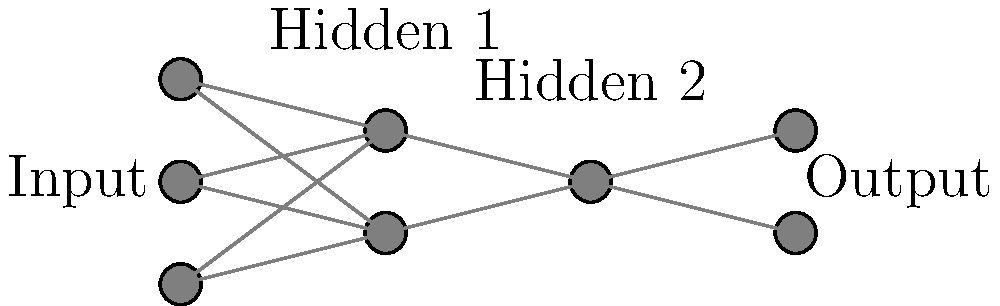Given the neural network architecture shown in the diagram, what is the total number of trainable parameters (weights and biases) in this network, assuming full connectivity between adjacent layers and the use of bias terms for each neuron except those in the input layer? To calculate the total number of trainable parameters, we need to count the weights and biases for each layer:

1. Count the number of neurons in each layer:
   - Input layer: 3 neurons
   - First hidden layer: 2 neurons
   - Second hidden layer: 1 neuron
   - Output layer: 2 neurons

2. Calculate weights between layers:
   - Input to First hidden: $3 \times 2 = 6$ weights
   - First hidden to Second hidden: $2 \times 1 = 2$ weights
   - Second hidden to Output: $1 \times 2 = 2$ weights

3. Calculate biases:
   - First hidden layer: 2 biases
   - Second hidden layer: 1 bias
   - Output layer: 2 biases

4. Sum up all parameters:
   - Total weights: $6 + 2 + 2 = 10$
   - Total biases: $2 + 1 + 2 = 5$
   - Total parameters: $10 + 5 = 15$

Therefore, the total number of trainable parameters in this neural network is 15.
Answer: 15 